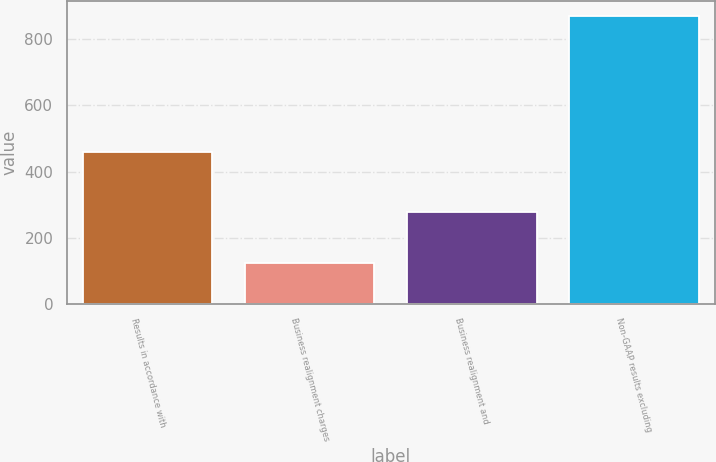Convert chart. <chart><loc_0><loc_0><loc_500><loc_500><bar_chart><fcel>Results in accordance with<fcel>Business realignment charges<fcel>Business realignment and<fcel>Non-GAAP results excluding<nl><fcel>458.8<fcel>123.1<fcel>276.9<fcel>871.4<nl></chart> 